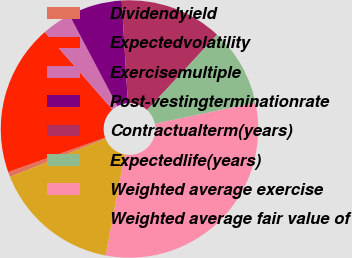Convert chart to OTSL. <chart><loc_0><loc_0><loc_500><loc_500><pie_chart><fcel>Dividendyield<fcel>Expectedvolatility<fcel>Exercisemultiple<fcel>Post-vestingterminationrate<fcel>Contractualterm(years)<fcel>Expectedlife(years)<fcel>Weighted average exercise<fcel>Weighted average fair value of<nl><fcel>0.64%<fcel>19.01%<fcel>3.7%<fcel>6.76%<fcel>12.88%<fcel>9.82%<fcel>31.24%<fcel>15.95%<nl></chart> 